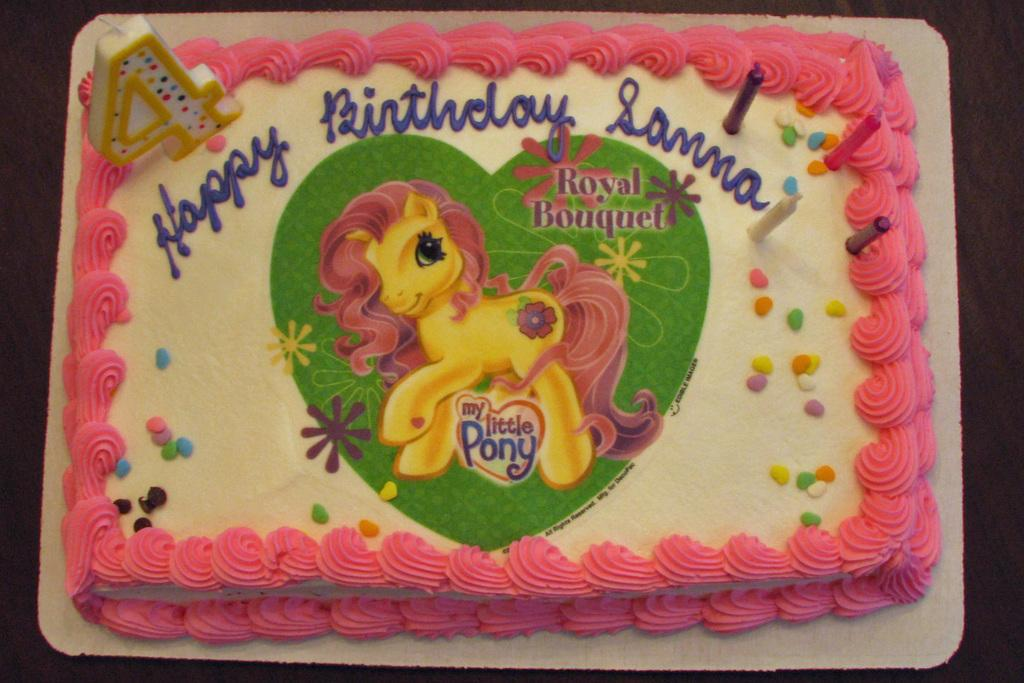What is the main subject of the image? The main subject of the image is a cake. What can be seen on the surface of the cake? The cake has an image on it and text. What is typically used to light a cake during a celebration? There are candles on the cake. What type of furniture is present in the image? There is no furniture present in the image; it only features a cake with candles, an image, and text. Can you touch the tramp in the image? There is no tramp present in the image; it only features a cake with candles, an image, and text. 